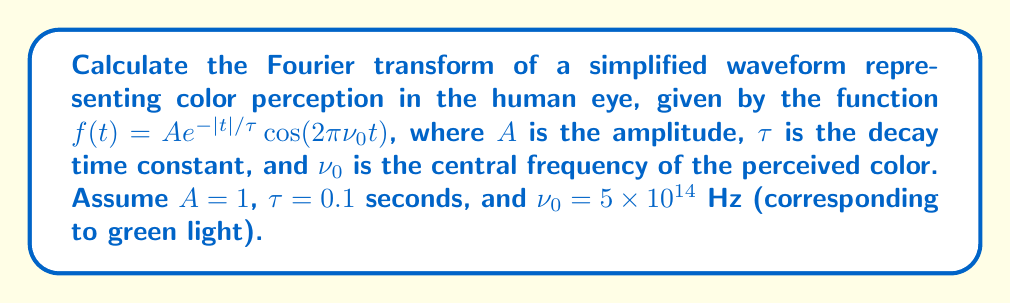Solve this math problem. Let's approach this step-by-step:

1) The Fourier transform of $f(t)$ is given by:

   $$F(\nu) = \int_{-\infty}^{\infty} f(t) e^{-2\pi i \nu t} dt$$

2) Substituting our function:

   $$F(\nu) = \int_{-\infty}^{\infty} e^{-|t|/\tau} \cos(2\pi \nu_0 t) e^{-2\pi i \nu t} dt$$

3) Using Euler's formula, $\cos(2\pi \nu_0 t) = \frac{1}{2}(e^{2\pi i \nu_0 t} + e^{-2\pi i \nu_0 t})$:

   $$F(\nu) = \frac{1}{2}\int_{-\infty}^{\infty} e^{-|t|/\tau} (e^{2\pi i \nu_0 t} + e^{-2\pi i \nu_0 t}) e^{-2\pi i \nu t} dt$$

4) This can be split into two integrals:

   $$F(\nu) = \frac{1}{2}\int_{-\infty}^{\infty} e^{-|t|/\tau} e^{2\pi i (\nu_0 - \nu) t} dt + \frac{1}{2}\int_{-\infty}^{\infty} e^{-|t|/\tau} e^{-2\pi i (\nu_0 + \nu) t} dt$$

5) Each of these integrals is of the form $\int_{-\infty}^{\infty} e^{-|t|/\tau} e^{-2\pi i \nu' t} dt$, which has a known solution:

   $$\frac{2\tau}{1 + (2\pi \nu' \tau)^2}$$

6) Applying this to our integrals:

   $$F(\nu) = \frac{\tau}{1 + (2\pi (\nu_0 - \nu) \tau)^2} + \frac{\tau}{1 + (2\pi (\nu_0 + \nu) \tau)^2}$$

7) Substituting the given values ($\tau = 0.1$ s, $\nu_0 = 5 \times 10^{14}$ Hz):

   $$F(\nu) = \frac{0.1}{1 + (2\pi (5 \times 10^{14} - \nu) 0.1)^2} + \frac{0.1}{1 + (2\pi (5 \times 10^{14} + \nu) 0.1)^2}$$

This is the Fourier transform of the given waveform.
Answer: $$F(\nu) = \frac{0.1}{1 + (2\pi (5 \times 10^{14} - \nu) 0.1)^2} + \frac{0.1}{1 + (2\pi (5 \times 10^{14} + \nu) 0.1)^2}$$ 